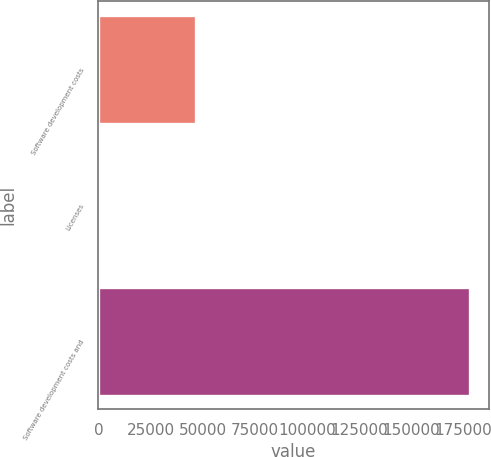Convert chart. <chart><loc_0><loc_0><loc_500><loc_500><bar_chart><fcel>Software development costs<fcel>Licenses<fcel>Software development costs and<nl><fcel>46888<fcel>121<fcel>178387<nl></chart> 